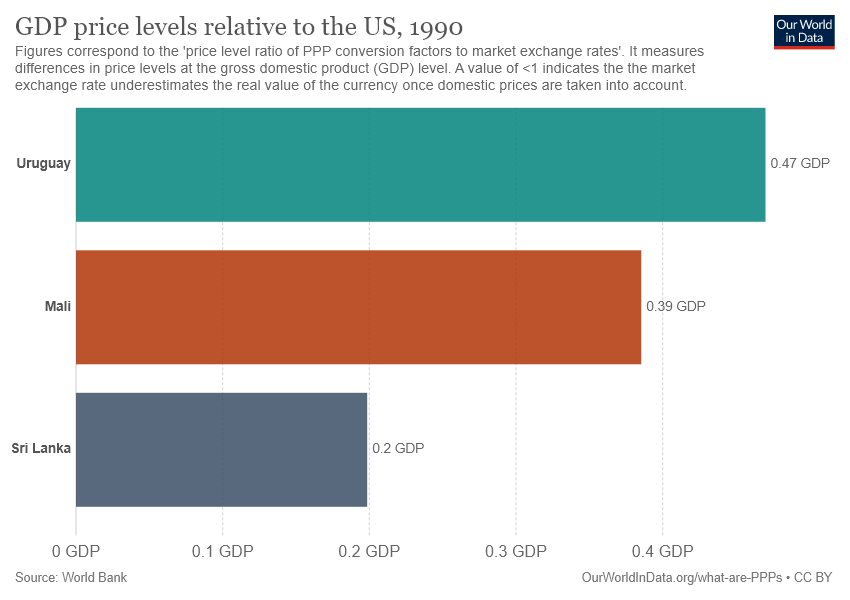Give some essential details in this illustration. The middle bar is brown in color. The sum of two low bars is not greater than Uruguay. 